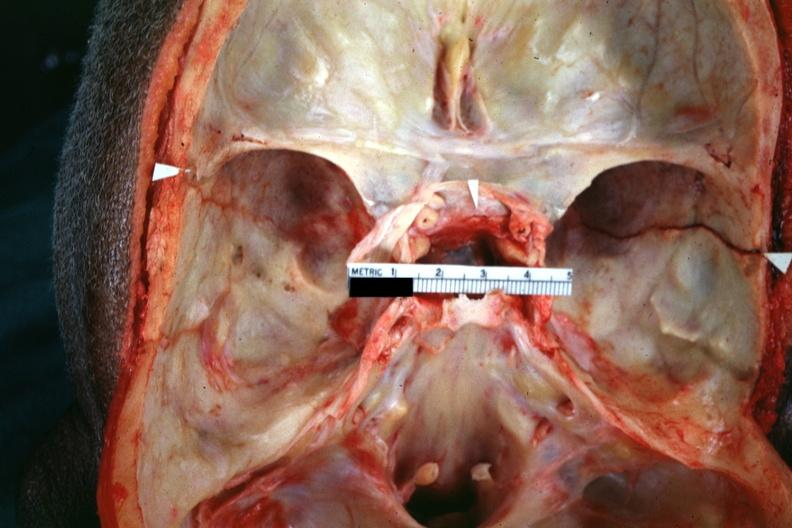what is present?
Answer the question using a single word or phrase. Basilar skull fracture 